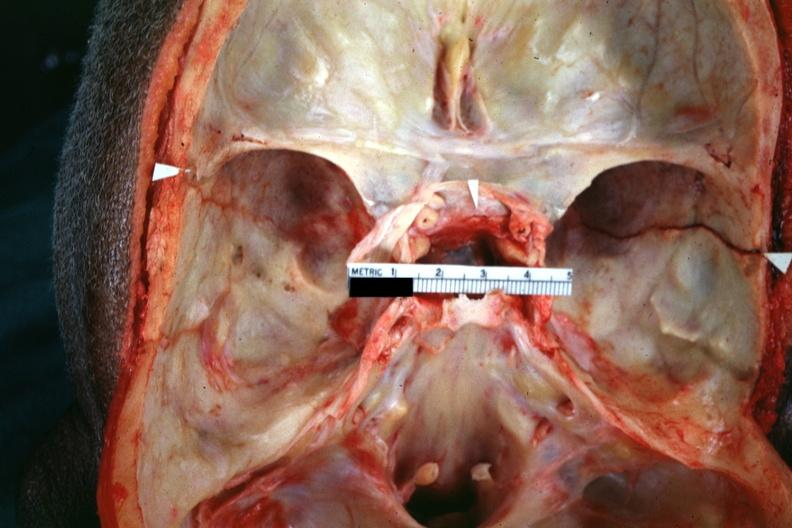what is present?
Answer the question using a single word or phrase. Basilar skull fracture 